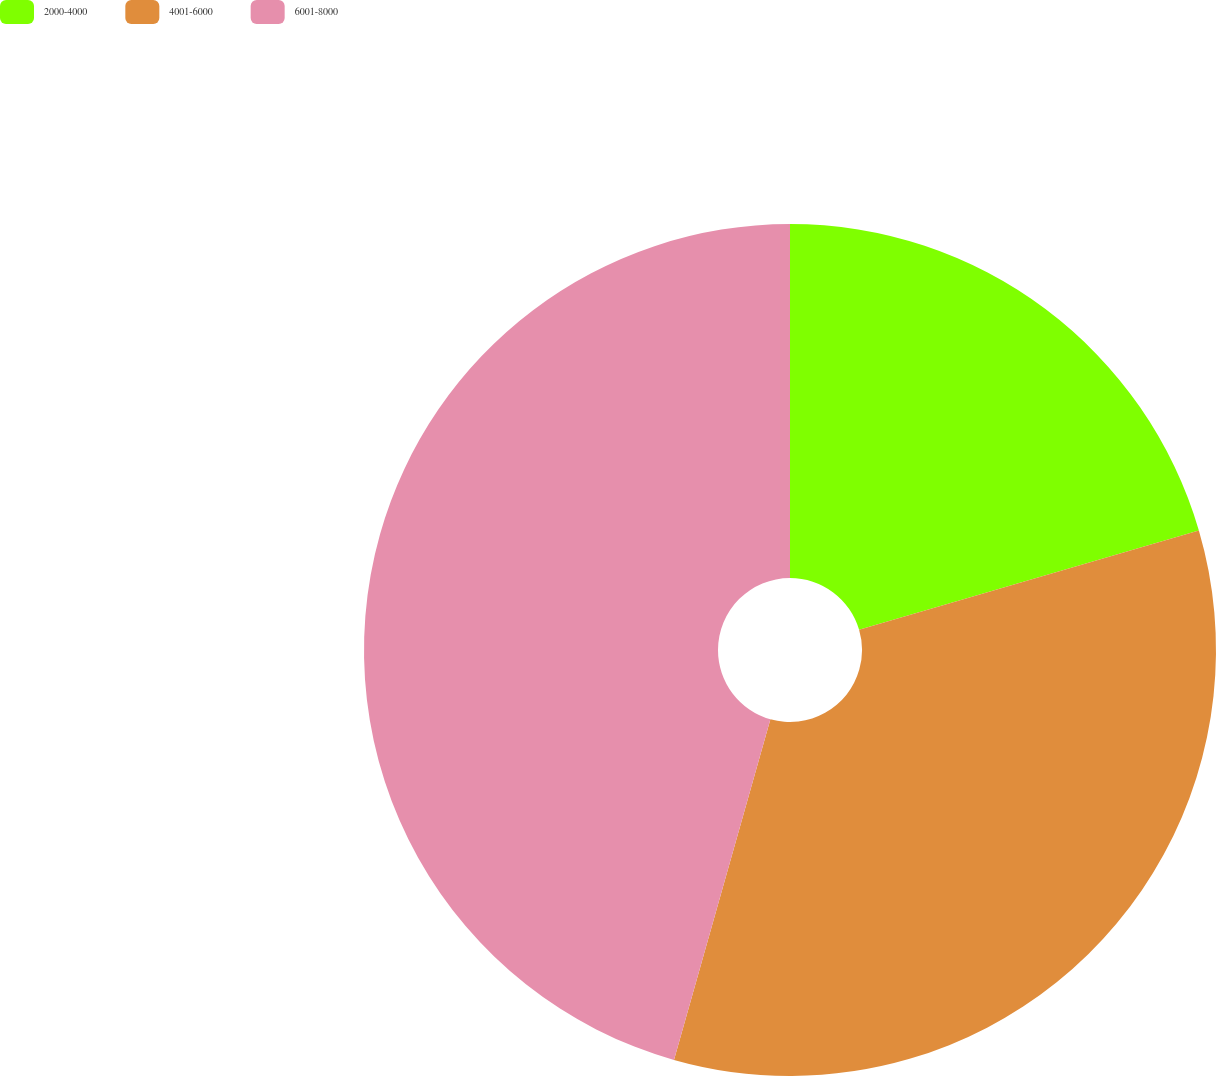Convert chart. <chart><loc_0><loc_0><loc_500><loc_500><pie_chart><fcel>2000-4000<fcel>4001-6000<fcel>6001-8000<nl><fcel>20.47%<fcel>33.92%<fcel>45.61%<nl></chart> 